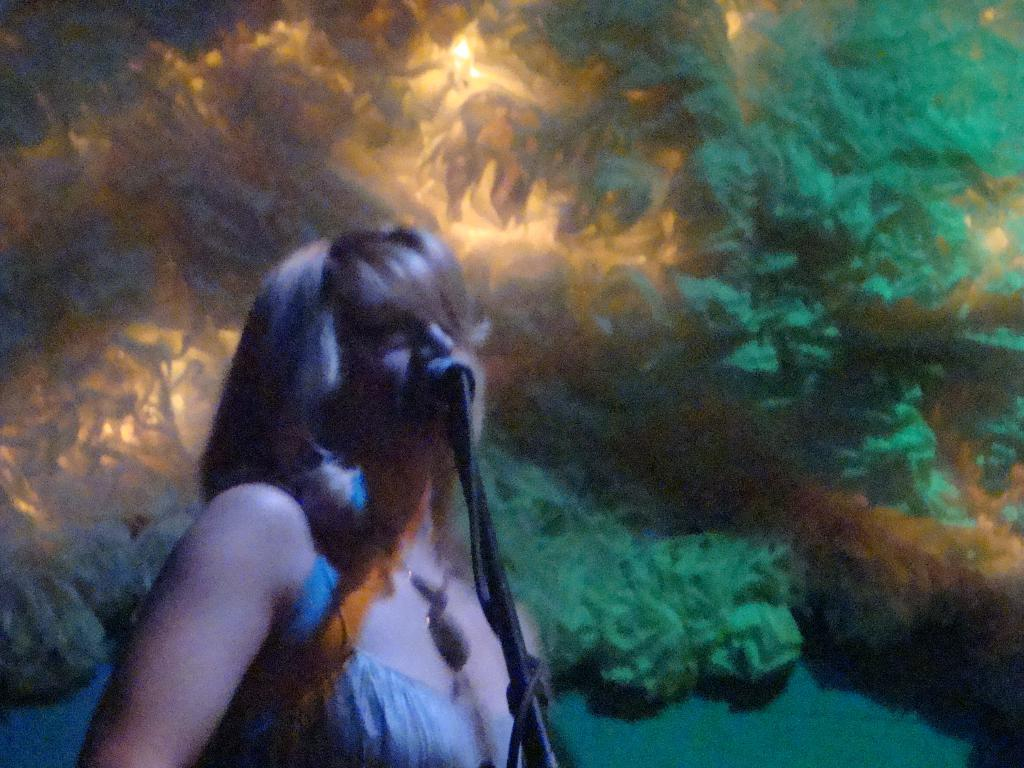What is present in the image? There is a person in the image. Can you describe the person's attire? The person is wearing clothes. What can be said about the background of the image? The background of the image is not clear. What type of noise is the bee making in the image? There is no bee present in the image, so it is not possible to determine what noise it might be making. 